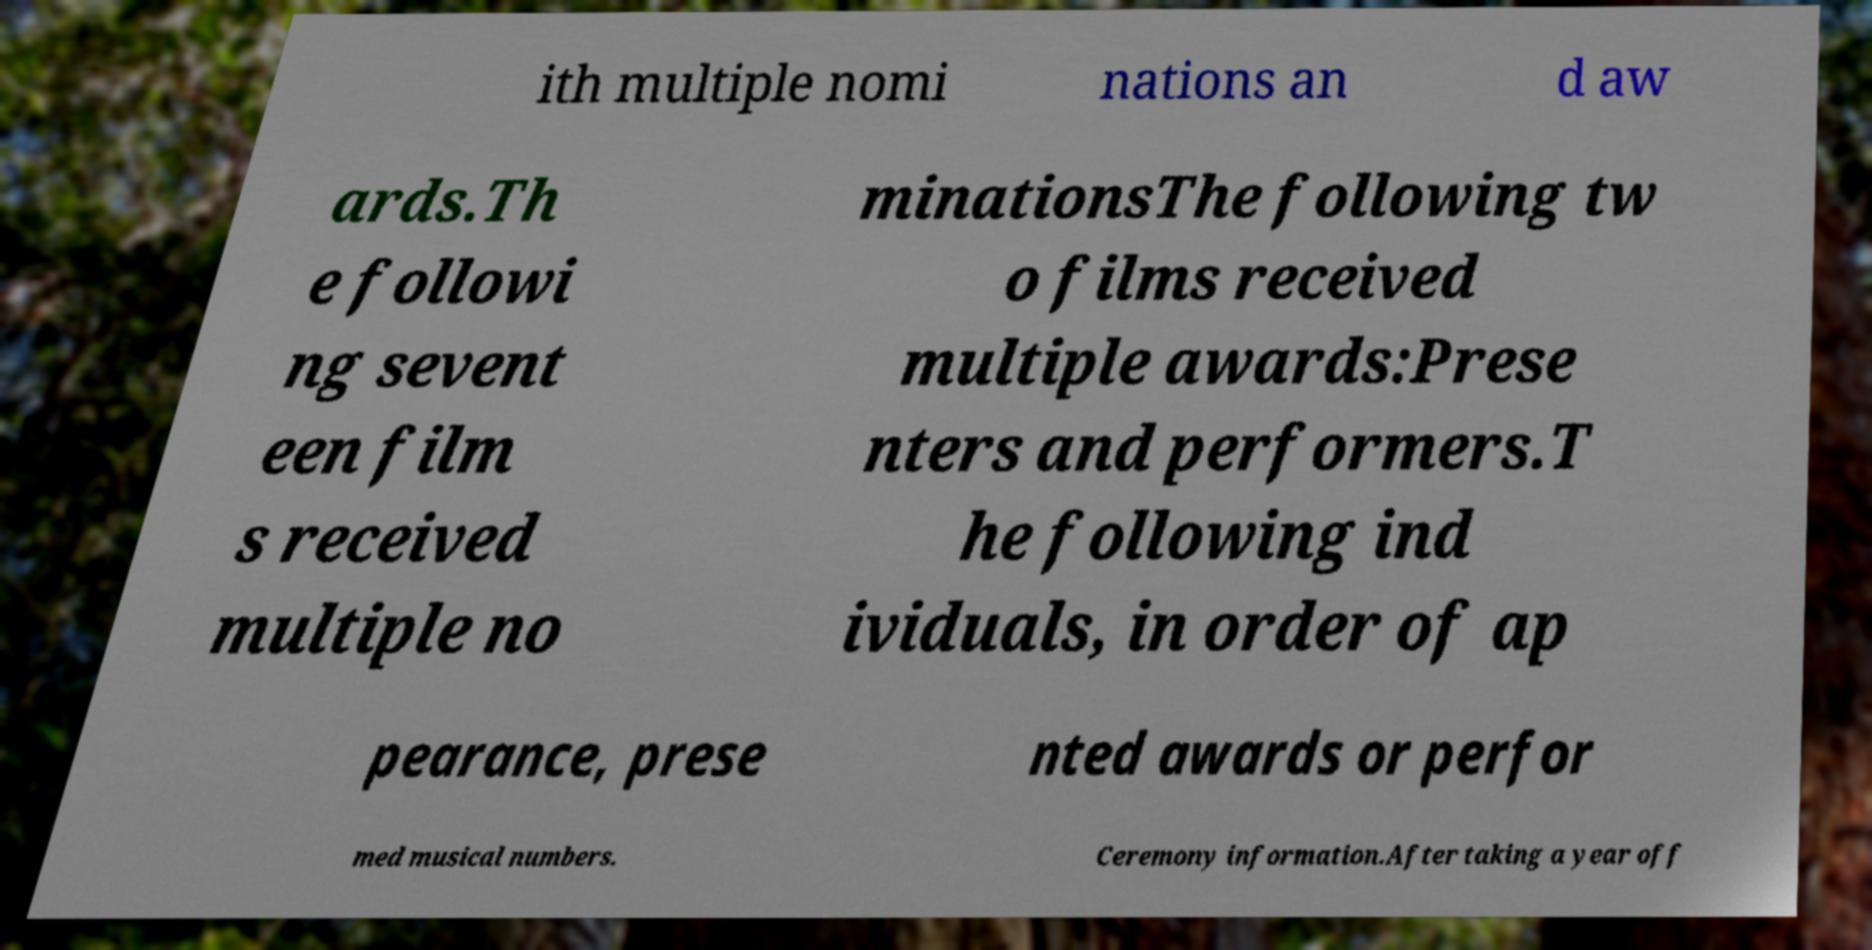Could you extract and type out the text from this image? ith multiple nomi nations an d aw ards.Th e followi ng sevent een film s received multiple no minationsThe following tw o films received multiple awards:Prese nters and performers.T he following ind ividuals, in order of ap pearance, prese nted awards or perfor med musical numbers. Ceremony information.After taking a year off 